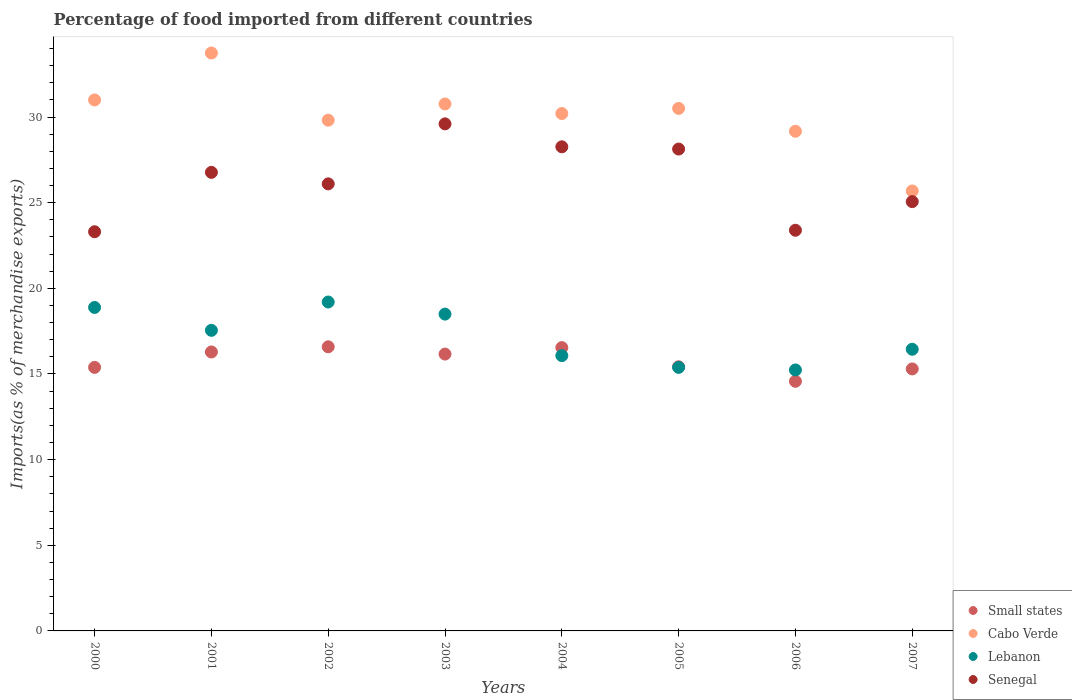What is the percentage of imports to different countries in Cabo Verde in 2002?
Make the answer very short. 29.82. Across all years, what is the maximum percentage of imports to different countries in Small states?
Offer a very short reply. 16.59. Across all years, what is the minimum percentage of imports to different countries in Senegal?
Keep it short and to the point. 23.3. In which year was the percentage of imports to different countries in Cabo Verde minimum?
Give a very brief answer. 2007. What is the total percentage of imports to different countries in Small states in the graph?
Your response must be concise. 126.25. What is the difference between the percentage of imports to different countries in Lebanon in 2002 and that in 2003?
Offer a terse response. 0.71. What is the difference between the percentage of imports to different countries in Senegal in 2006 and the percentage of imports to different countries in Small states in 2004?
Make the answer very short. 6.85. What is the average percentage of imports to different countries in Senegal per year?
Provide a short and direct response. 26.33. In the year 2001, what is the difference between the percentage of imports to different countries in Small states and percentage of imports to different countries in Senegal?
Provide a succinct answer. -10.49. What is the ratio of the percentage of imports to different countries in Lebanon in 2001 to that in 2003?
Offer a terse response. 0.95. What is the difference between the highest and the second highest percentage of imports to different countries in Senegal?
Provide a succinct answer. 1.34. What is the difference between the highest and the lowest percentage of imports to different countries in Small states?
Ensure brevity in your answer.  2.01. In how many years, is the percentage of imports to different countries in Lebanon greater than the average percentage of imports to different countries in Lebanon taken over all years?
Provide a short and direct response. 4. Is the sum of the percentage of imports to different countries in Lebanon in 2000 and 2006 greater than the maximum percentage of imports to different countries in Small states across all years?
Your answer should be compact. Yes. Is it the case that in every year, the sum of the percentage of imports to different countries in Senegal and percentage of imports to different countries in Cabo Verde  is greater than the percentage of imports to different countries in Lebanon?
Make the answer very short. Yes. Is the percentage of imports to different countries in Small states strictly greater than the percentage of imports to different countries in Lebanon over the years?
Offer a very short reply. No. How many years are there in the graph?
Your answer should be very brief. 8. What is the difference between two consecutive major ticks on the Y-axis?
Ensure brevity in your answer.  5. Are the values on the major ticks of Y-axis written in scientific E-notation?
Keep it short and to the point. No. Does the graph contain any zero values?
Your answer should be compact. No. How many legend labels are there?
Give a very brief answer. 4. What is the title of the graph?
Give a very brief answer. Percentage of food imported from different countries. What is the label or title of the Y-axis?
Ensure brevity in your answer.  Imports(as % of merchandise exports). What is the Imports(as % of merchandise exports) of Small states in 2000?
Provide a short and direct response. 15.39. What is the Imports(as % of merchandise exports) in Cabo Verde in 2000?
Offer a very short reply. 31. What is the Imports(as % of merchandise exports) of Lebanon in 2000?
Offer a very short reply. 18.88. What is the Imports(as % of merchandise exports) of Senegal in 2000?
Offer a terse response. 23.3. What is the Imports(as % of merchandise exports) in Small states in 2001?
Your answer should be very brief. 16.29. What is the Imports(as % of merchandise exports) in Cabo Verde in 2001?
Offer a very short reply. 33.74. What is the Imports(as % of merchandise exports) of Lebanon in 2001?
Ensure brevity in your answer.  17.55. What is the Imports(as % of merchandise exports) of Senegal in 2001?
Provide a short and direct response. 26.77. What is the Imports(as % of merchandise exports) in Small states in 2002?
Your answer should be very brief. 16.59. What is the Imports(as % of merchandise exports) in Cabo Verde in 2002?
Provide a short and direct response. 29.82. What is the Imports(as % of merchandise exports) in Lebanon in 2002?
Provide a short and direct response. 19.2. What is the Imports(as % of merchandise exports) in Senegal in 2002?
Ensure brevity in your answer.  26.1. What is the Imports(as % of merchandise exports) of Small states in 2003?
Your response must be concise. 16.16. What is the Imports(as % of merchandise exports) of Cabo Verde in 2003?
Your response must be concise. 30.76. What is the Imports(as % of merchandise exports) of Lebanon in 2003?
Offer a very short reply. 18.5. What is the Imports(as % of merchandise exports) of Senegal in 2003?
Provide a succinct answer. 29.6. What is the Imports(as % of merchandise exports) in Small states in 2004?
Your answer should be compact. 16.54. What is the Imports(as % of merchandise exports) of Cabo Verde in 2004?
Keep it short and to the point. 30.21. What is the Imports(as % of merchandise exports) of Lebanon in 2004?
Your answer should be compact. 16.07. What is the Imports(as % of merchandise exports) of Senegal in 2004?
Give a very brief answer. 28.26. What is the Imports(as % of merchandise exports) in Small states in 2005?
Your answer should be very brief. 15.42. What is the Imports(as % of merchandise exports) in Cabo Verde in 2005?
Ensure brevity in your answer.  30.51. What is the Imports(as % of merchandise exports) of Lebanon in 2005?
Provide a succinct answer. 15.39. What is the Imports(as % of merchandise exports) of Senegal in 2005?
Give a very brief answer. 28.13. What is the Imports(as % of merchandise exports) of Small states in 2006?
Your response must be concise. 14.57. What is the Imports(as % of merchandise exports) of Cabo Verde in 2006?
Provide a short and direct response. 29.17. What is the Imports(as % of merchandise exports) of Lebanon in 2006?
Offer a very short reply. 15.24. What is the Imports(as % of merchandise exports) in Senegal in 2006?
Offer a terse response. 23.39. What is the Imports(as % of merchandise exports) of Small states in 2007?
Offer a very short reply. 15.3. What is the Imports(as % of merchandise exports) of Cabo Verde in 2007?
Ensure brevity in your answer.  25.69. What is the Imports(as % of merchandise exports) of Lebanon in 2007?
Give a very brief answer. 16.44. What is the Imports(as % of merchandise exports) in Senegal in 2007?
Offer a very short reply. 25.06. Across all years, what is the maximum Imports(as % of merchandise exports) in Small states?
Provide a succinct answer. 16.59. Across all years, what is the maximum Imports(as % of merchandise exports) of Cabo Verde?
Offer a very short reply. 33.74. Across all years, what is the maximum Imports(as % of merchandise exports) of Lebanon?
Keep it short and to the point. 19.2. Across all years, what is the maximum Imports(as % of merchandise exports) of Senegal?
Give a very brief answer. 29.6. Across all years, what is the minimum Imports(as % of merchandise exports) in Small states?
Your answer should be compact. 14.57. Across all years, what is the minimum Imports(as % of merchandise exports) of Cabo Verde?
Keep it short and to the point. 25.69. Across all years, what is the minimum Imports(as % of merchandise exports) of Lebanon?
Provide a short and direct response. 15.24. Across all years, what is the minimum Imports(as % of merchandise exports) of Senegal?
Offer a very short reply. 23.3. What is the total Imports(as % of merchandise exports) of Small states in the graph?
Provide a short and direct response. 126.25. What is the total Imports(as % of merchandise exports) in Cabo Verde in the graph?
Provide a short and direct response. 240.89. What is the total Imports(as % of merchandise exports) in Lebanon in the graph?
Your response must be concise. 137.27. What is the total Imports(as % of merchandise exports) in Senegal in the graph?
Give a very brief answer. 210.63. What is the difference between the Imports(as % of merchandise exports) of Small states in 2000 and that in 2001?
Ensure brevity in your answer.  -0.9. What is the difference between the Imports(as % of merchandise exports) in Cabo Verde in 2000 and that in 2001?
Make the answer very short. -2.74. What is the difference between the Imports(as % of merchandise exports) of Lebanon in 2000 and that in 2001?
Give a very brief answer. 1.34. What is the difference between the Imports(as % of merchandise exports) in Senegal in 2000 and that in 2001?
Make the answer very short. -3.47. What is the difference between the Imports(as % of merchandise exports) in Small states in 2000 and that in 2002?
Offer a terse response. -1.2. What is the difference between the Imports(as % of merchandise exports) in Cabo Verde in 2000 and that in 2002?
Offer a very short reply. 1.18. What is the difference between the Imports(as % of merchandise exports) of Lebanon in 2000 and that in 2002?
Make the answer very short. -0.32. What is the difference between the Imports(as % of merchandise exports) of Senegal in 2000 and that in 2002?
Make the answer very short. -2.8. What is the difference between the Imports(as % of merchandise exports) of Small states in 2000 and that in 2003?
Offer a terse response. -0.78. What is the difference between the Imports(as % of merchandise exports) in Cabo Verde in 2000 and that in 2003?
Ensure brevity in your answer.  0.24. What is the difference between the Imports(as % of merchandise exports) of Lebanon in 2000 and that in 2003?
Your answer should be compact. 0.39. What is the difference between the Imports(as % of merchandise exports) in Senegal in 2000 and that in 2003?
Your answer should be compact. -6.3. What is the difference between the Imports(as % of merchandise exports) of Small states in 2000 and that in 2004?
Ensure brevity in your answer.  -1.15. What is the difference between the Imports(as % of merchandise exports) in Cabo Verde in 2000 and that in 2004?
Offer a terse response. 0.79. What is the difference between the Imports(as % of merchandise exports) of Lebanon in 2000 and that in 2004?
Give a very brief answer. 2.81. What is the difference between the Imports(as % of merchandise exports) of Senegal in 2000 and that in 2004?
Give a very brief answer. -4.96. What is the difference between the Imports(as % of merchandise exports) in Small states in 2000 and that in 2005?
Offer a terse response. -0.03. What is the difference between the Imports(as % of merchandise exports) in Cabo Verde in 2000 and that in 2005?
Your response must be concise. 0.49. What is the difference between the Imports(as % of merchandise exports) of Lebanon in 2000 and that in 2005?
Your response must be concise. 3.5. What is the difference between the Imports(as % of merchandise exports) of Senegal in 2000 and that in 2005?
Your answer should be compact. -4.83. What is the difference between the Imports(as % of merchandise exports) of Small states in 2000 and that in 2006?
Make the answer very short. 0.81. What is the difference between the Imports(as % of merchandise exports) in Cabo Verde in 2000 and that in 2006?
Ensure brevity in your answer.  1.83. What is the difference between the Imports(as % of merchandise exports) of Lebanon in 2000 and that in 2006?
Offer a terse response. 3.65. What is the difference between the Imports(as % of merchandise exports) of Senegal in 2000 and that in 2006?
Your answer should be very brief. -0.09. What is the difference between the Imports(as % of merchandise exports) of Small states in 2000 and that in 2007?
Your response must be concise. 0.09. What is the difference between the Imports(as % of merchandise exports) in Cabo Verde in 2000 and that in 2007?
Your answer should be very brief. 5.31. What is the difference between the Imports(as % of merchandise exports) of Lebanon in 2000 and that in 2007?
Offer a terse response. 2.44. What is the difference between the Imports(as % of merchandise exports) in Senegal in 2000 and that in 2007?
Ensure brevity in your answer.  -1.76. What is the difference between the Imports(as % of merchandise exports) in Small states in 2001 and that in 2002?
Give a very brief answer. -0.3. What is the difference between the Imports(as % of merchandise exports) of Cabo Verde in 2001 and that in 2002?
Your response must be concise. 3.92. What is the difference between the Imports(as % of merchandise exports) in Lebanon in 2001 and that in 2002?
Your answer should be compact. -1.65. What is the difference between the Imports(as % of merchandise exports) of Senegal in 2001 and that in 2002?
Offer a terse response. 0.67. What is the difference between the Imports(as % of merchandise exports) in Small states in 2001 and that in 2003?
Provide a short and direct response. 0.12. What is the difference between the Imports(as % of merchandise exports) of Cabo Verde in 2001 and that in 2003?
Keep it short and to the point. 2.98. What is the difference between the Imports(as % of merchandise exports) in Lebanon in 2001 and that in 2003?
Your answer should be very brief. -0.95. What is the difference between the Imports(as % of merchandise exports) in Senegal in 2001 and that in 2003?
Keep it short and to the point. -2.83. What is the difference between the Imports(as % of merchandise exports) of Small states in 2001 and that in 2004?
Your answer should be compact. -0.25. What is the difference between the Imports(as % of merchandise exports) of Cabo Verde in 2001 and that in 2004?
Provide a short and direct response. 3.53. What is the difference between the Imports(as % of merchandise exports) of Lebanon in 2001 and that in 2004?
Your answer should be very brief. 1.48. What is the difference between the Imports(as % of merchandise exports) in Senegal in 2001 and that in 2004?
Your answer should be compact. -1.49. What is the difference between the Imports(as % of merchandise exports) in Small states in 2001 and that in 2005?
Make the answer very short. 0.86. What is the difference between the Imports(as % of merchandise exports) of Cabo Verde in 2001 and that in 2005?
Your answer should be compact. 3.24. What is the difference between the Imports(as % of merchandise exports) in Lebanon in 2001 and that in 2005?
Your response must be concise. 2.16. What is the difference between the Imports(as % of merchandise exports) of Senegal in 2001 and that in 2005?
Provide a short and direct response. -1.36. What is the difference between the Imports(as % of merchandise exports) in Small states in 2001 and that in 2006?
Provide a short and direct response. 1.71. What is the difference between the Imports(as % of merchandise exports) in Cabo Verde in 2001 and that in 2006?
Provide a short and direct response. 4.57. What is the difference between the Imports(as % of merchandise exports) in Lebanon in 2001 and that in 2006?
Ensure brevity in your answer.  2.31. What is the difference between the Imports(as % of merchandise exports) in Senegal in 2001 and that in 2006?
Provide a succinct answer. 3.38. What is the difference between the Imports(as % of merchandise exports) in Cabo Verde in 2001 and that in 2007?
Offer a very short reply. 8.05. What is the difference between the Imports(as % of merchandise exports) in Lebanon in 2001 and that in 2007?
Offer a very short reply. 1.1. What is the difference between the Imports(as % of merchandise exports) of Senegal in 2001 and that in 2007?
Ensure brevity in your answer.  1.71. What is the difference between the Imports(as % of merchandise exports) in Small states in 2002 and that in 2003?
Ensure brevity in your answer.  0.42. What is the difference between the Imports(as % of merchandise exports) in Cabo Verde in 2002 and that in 2003?
Provide a succinct answer. -0.95. What is the difference between the Imports(as % of merchandise exports) in Lebanon in 2002 and that in 2003?
Make the answer very short. 0.71. What is the difference between the Imports(as % of merchandise exports) of Senegal in 2002 and that in 2003?
Your response must be concise. -3.5. What is the difference between the Imports(as % of merchandise exports) of Small states in 2002 and that in 2004?
Ensure brevity in your answer.  0.05. What is the difference between the Imports(as % of merchandise exports) of Cabo Verde in 2002 and that in 2004?
Offer a very short reply. -0.39. What is the difference between the Imports(as % of merchandise exports) in Lebanon in 2002 and that in 2004?
Ensure brevity in your answer.  3.13. What is the difference between the Imports(as % of merchandise exports) of Senegal in 2002 and that in 2004?
Keep it short and to the point. -2.16. What is the difference between the Imports(as % of merchandise exports) in Small states in 2002 and that in 2005?
Your answer should be very brief. 1.17. What is the difference between the Imports(as % of merchandise exports) of Cabo Verde in 2002 and that in 2005?
Your answer should be very brief. -0.69. What is the difference between the Imports(as % of merchandise exports) in Lebanon in 2002 and that in 2005?
Provide a short and direct response. 3.81. What is the difference between the Imports(as % of merchandise exports) in Senegal in 2002 and that in 2005?
Offer a terse response. -2.03. What is the difference between the Imports(as % of merchandise exports) of Small states in 2002 and that in 2006?
Offer a very short reply. 2.01. What is the difference between the Imports(as % of merchandise exports) in Cabo Verde in 2002 and that in 2006?
Give a very brief answer. 0.65. What is the difference between the Imports(as % of merchandise exports) of Lebanon in 2002 and that in 2006?
Offer a terse response. 3.97. What is the difference between the Imports(as % of merchandise exports) in Senegal in 2002 and that in 2006?
Your response must be concise. 2.71. What is the difference between the Imports(as % of merchandise exports) of Small states in 2002 and that in 2007?
Give a very brief answer. 1.29. What is the difference between the Imports(as % of merchandise exports) in Cabo Verde in 2002 and that in 2007?
Make the answer very short. 4.13. What is the difference between the Imports(as % of merchandise exports) in Lebanon in 2002 and that in 2007?
Your answer should be very brief. 2.76. What is the difference between the Imports(as % of merchandise exports) in Senegal in 2002 and that in 2007?
Keep it short and to the point. 1.04. What is the difference between the Imports(as % of merchandise exports) of Small states in 2003 and that in 2004?
Your response must be concise. -0.38. What is the difference between the Imports(as % of merchandise exports) of Cabo Verde in 2003 and that in 2004?
Give a very brief answer. 0.56. What is the difference between the Imports(as % of merchandise exports) in Lebanon in 2003 and that in 2004?
Keep it short and to the point. 2.42. What is the difference between the Imports(as % of merchandise exports) in Senegal in 2003 and that in 2004?
Keep it short and to the point. 1.34. What is the difference between the Imports(as % of merchandise exports) of Small states in 2003 and that in 2005?
Give a very brief answer. 0.74. What is the difference between the Imports(as % of merchandise exports) of Cabo Verde in 2003 and that in 2005?
Give a very brief answer. 0.26. What is the difference between the Imports(as % of merchandise exports) in Lebanon in 2003 and that in 2005?
Your response must be concise. 3.11. What is the difference between the Imports(as % of merchandise exports) in Senegal in 2003 and that in 2005?
Ensure brevity in your answer.  1.47. What is the difference between the Imports(as % of merchandise exports) in Small states in 2003 and that in 2006?
Give a very brief answer. 1.59. What is the difference between the Imports(as % of merchandise exports) in Cabo Verde in 2003 and that in 2006?
Offer a very short reply. 1.59. What is the difference between the Imports(as % of merchandise exports) of Lebanon in 2003 and that in 2006?
Give a very brief answer. 3.26. What is the difference between the Imports(as % of merchandise exports) in Senegal in 2003 and that in 2006?
Offer a terse response. 6.21. What is the difference between the Imports(as % of merchandise exports) in Small states in 2003 and that in 2007?
Offer a very short reply. 0.87. What is the difference between the Imports(as % of merchandise exports) of Cabo Verde in 2003 and that in 2007?
Offer a terse response. 5.08. What is the difference between the Imports(as % of merchandise exports) of Lebanon in 2003 and that in 2007?
Make the answer very short. 2.05. What is the difference between the Imports(as % of merchandise exports) in Senegal in 2003 and that in 2007?
Provide a succinct answer. 4.54. What is the difference between the Imports(as % of merchandise exports) of Small states in 2004 and that in 2005?
Keep it short and to the point. 1.12. What is the difference between the Imports(as % of merchandise exports) in Cabo Verde in 2004 and that in 2005?
Your answer should be compact. -0.3. What is the difference between the Imports(as % of merchandise exports) in Lebanon in 2004 and that in 2005?
Make the answer very short. 0.69. What is the difference between the Imports(as % of merchandise exports) in Senegal in 2004 and that in 2005?
Provide a succinct answer. 0.13. What is the difference between the Imports(as % of merchandise exports) in Small states in 2004 and that in 2006?
Offer a terse response. 1.97. What is the difference between the Imports(as % of merchandise exports) in Cabo Verde in 2004 and that in 2006?
Your response must be concise. 1.04. What is the difference between the Imports(as % of merchandise exports) of Lebanon in 2004 and that in 2006?
Keep it short and to the point. 0.84. What is the difference between the Imports(as % of merchandise exports) of Senegal in 2004 and that in 2006?
Your answer should be compact. 4.87. What is the difference between the Imports(as % of merchandise exports) of Small states in 2004 and that in 2007?
Make the answer very short. 1.24. What is the difference between the Imports(as % of merchandise exports) in Cabo Verde in 2004 and that in 2007?
Provide a short and direct response. 4.52. What is the difference between the Imports(as % of merchandise exports) of Lebanon in 2004 and that in 2007?
Keep it short and to the point. -0.37. What is the difference between the Imports(as % of merchandise exports) in Senegal in 2004 and that in 2007?
Your response must be concise. 3.2. What is the difference between the Imports(as % of merchandise exports) of Small states in 2005 and that in 2006?
Provide a succinct answer. 0.85. What is the difference between the Imports(as % of merchandise exports) in Cabo Verde in 2005 and that in 2006?
Provide a succinct answer. 1.33. What is the difference between the Imports(as % of merchandise exports) of Lebanon in 2005 and that in 2006?
Your answer should be very brief. 0.15. What is the difference between the Imports(as % of merchandise exports) of Senegal in 2005 and that in 2006?
Your response must be concise. 4.74. What is the difference between the Imports(as % of merchandise exports) of Small states in 2005 and that in 2007?
Offer a terse response. 0.13. What is the difference between the Imports(as % of merchandise exports) in Cabo Verde in 2005 and that in 2007?
Your response must be concise. 4.82. What is the difference between the Imports(as % of merchandise exports) of Lebanon in 2005 and that in 2007?
Ensure brevity in your answer.  -1.06. What is the difference between the Imports(as % of merchandise exports) of Senegal in 2005 and that in 2007?
Give a very brief answer. 3.07. What is the difference between the Imports(as % of merchandise exports) in Small states in 2006 and that in 2007?
Your answer should be very brief. -0.72. What is the difference between the Imports(as % of merchandise exports) of Cabo Verde in 2006 and that in 2007?
Provide a succinct answer. 3.48. What is the difference between the Imports(as % of merchandise exports) of Lebanon in 2006 and that in 2007?
Provide a succinct answer. -1.21. What is the difference between the Imports(as % of merchandise exports) of Senegal in 2006 and that in 2007?
Your answer should be very brief. -1.67. What is the difference between the Imports(as % of merchandise exports) in Small states in 2000 and the Imports(as % of merchandise exports) in Cabo Verde in 2001?
Give a very brief answer. -18.35. What is the difference between the Imports(as % of merchandise exports) in Small states in 2000 and the Imports(as % of merchandise exports) in Lebanon in 2001?
Your answer should be very brief. -2.16. What is the difference between the Imports(as % of merchandise exports) in Small states in 2000 and the Imports(as % of merchandise exports) in Senegal in 2001?
Give a very brief answer. -11.38. What is the difference between the Imports(as % of merchandise exports) in Cabo Verde in 2000 and the Imports(as % of merchandise exports) in Lebanon in 2001?
Your answer should be very brief. 13.45. What is the difference between the Imports(as % of merchandise exports) in Cabo Verde in 2000 and the Imports(as % of merchandise exports) in Senegal in 2001?
Offer a terse response. 4.23. What is the difference between the Imports(as % of merchandise exports) in Lebanon in 2000 and the Imports(as % of merchandise exports) in Senegal in 2001?
Keep it short and to the point. -7.89. What is the difference between the Imports(as % of merchandise exports) in Small states in 2000 and the Imports(as % of merchandise exports) in Cabo Verde in 2002?
Your answer should be very brief. -14.43. What is the difference between the Imports(as % of merchandise exports) in Small states in 2000 and the Imports(as % of merchandise exports) in Lebanon in 2002?
Make the answer very short. -3.82. What is the difference between the Imports(as % of merchandise exports) of Small states in 2000 and the Imports(as % of merchandise exports) of Senegal in 2002?
Ensure brevity in your answer.  -10.71. What is the difference between the Imports(as % of merchandise exports) of Cabo Verde in 2000 and the Imports(as % of merchandise exports) of Lebanon in 2002?
Give a very brief answer. 11.8. What is the difference between the Imports(as % of merchandise exports) in Cabo Verde in 2000 and the Imports(as % of merchandise exports) in Senegal in 2002?
Offer a very short reply. 4.9. What is the difference between the Imports(as % of merchandise exports) of Lebanon in 2000 and the Imports(as % of merchandise exports) of Senegal in 2002?
Your response must be concise. -7.22. What is the difference between the Imports(as % of merchandise exports) in Small states in 2000 and the Imports(as % of merchandise exports) in Cabo Verde in 2003?
Keep it short and to the point. -15.38. What is the difference between the Imports(as % of merchandise exports) of Small states in 2000 and the Imports(as % of merchandise exports) of Lebanon in 2003?
Offer a terse response. -3.11. What is the difference between the Imports(as % of merchandise exports) in Small states in 2000 and the Imports(as % of merchandise exports) in Senegal in 2003?
Ensure brevity in your answer.  -14.22. What is the difference between the Imports(as % of merchandise exports) of Cabo Verde in 2000 and the Imports(as % of merchandise exports) of Lebanon in 2003?
Your answer should be very brief. 12.5. What is the difference between the Imports(as % of merchandise exports) in Cabo Verde in 2000 and the Imports(as % of merchandise exports) in Senegal in 2003?
Ensure brevity in your answer.  1.4. What is the difference between the Imports(as % of merchandise exports) of Lebanon in 2000 and the Imports(as % of merchandise exports) of Senegal in 2003?
Give a very brief answer. -10.72. What is the difference between the Imports(as % of merchandise exports) in Small states in 2000 and the Imports(as % of merchandise exports) in Cabo Verde in 2004?
Offer a terse response. -14.82. What is the difference between the Imports(as % of merchandise exports) in Small states in 2000 and the Imports(as % of merchandise exports) in Lebanon in 2004?
Keep it short and to the point. -0.69. What is the difference between the Imports(as % of merchandise exports) in Small states in 2000 and the Imports(as % of merchandise exports) in Senegal in 2004?
Offer a terse response. -12.88. What is the difference between the Imports(as % of merchandise exports) in Cabo Verde in 2000 and the Imports(as % of merchandise exports) in Lebanon in 2004?
Provide a succinct answer. 14.93. What is the difference between the Imports(as % of merchandise exports) in Cabo Verde in 2000 and the Imports(as % of merchandise exports) in Senegal in 2004?
Your answer should be very brief. 2.74. What is the difference between the Imports(as % of merchandise exports) in Lebanon in 2000 and the Imports(as % of merchandise exports) in Senegal in 2004?
Keep it short and to the point. -9.38. What is the difference between the Imports(as % of merchandise exports) of Small states in 2000 and the Imports(as % of merchandise exports) of Cabo Verde in 2005?
Ensure brevity in your answer.  -15.12. What is the difference between the Imports(as % of merchandise exports) in Small states in 2000 and the Imports(as % of merchandise exports) in Lebanon in 2005?
Ensure brevity in your answer.  -0. What is the difference between the Imports(as % of merchandise exports) in Small states in 2000 and the Imports(as % of merchandise exports) in Senegal in 2005?
Ensure brevity in your answer.  -12.75. What is the difference between the Imports(as % of merchandise exports) in Cabo Verde in 2000 and the Imports(as % of merchandise exports) in Lebanon in 2005?
Your answer should be very brief. 15.61. What is the difference between the Imports(as % of merchandise exports) of Cabo Verde in 2000 and the Imports(as % of merchandise exports) of Senegal in 2005?
Offer a very short reply. 2.87. What is the difference between the Imports(as % of merchandise exports) of Lebanon in 2000 and the Imports(as % of merchandise exports) of Senegal in 2005?
Provide a short and direct response. -9.25. What is the difference between the Imports(as % of merchandise exports) of Small states in 2000 and the Imports(as % of merchandise exports) of Cabo Verde in 2006?
Offer a terse response. -13.78. What is the difference between the Imports(as % of merchandise exports) of Small states in 2000 and the Imports(as % of merchandise exports) of Lebanon in 2006?
Your answer should be compact. 0.15. What is the difference between the Imports(as % of merchandise exports) of Small states in 2000 and the Imports(as % of merchandise exports) of Senegal in 2006?
Your response must be concise. -8.01. What is the difference between the Imports(as % of merchandise exports) in Cabo Verde in 2000 and the Imports(as % of merchandise exports) in Lebanon in 2006?
Offer a very short reply. 15.76. What is the difference between the Imports(as % of merchandise exports) of Cabo Verde in 2000 and the Imports(as % of merchandise exports) of Senegal in 2006?
Provide a succinct answer. 7.61. What is the difference between the Imports(as % of merchandise exports) of Lebanon in 2000 and the Imports(as % of merchandise exports) of Senegal in 2006?
Offer a terse response. -4.51. What is the difference between the Imports(as % of merchandise exports) of Small states in 2000 and the Imports(as % of merchandise exports) of Cabo Verde in 2007?
Offer a very short reply. -10.3. What is the difference between the Imports(as % of merchandise exports) of Small states in 2000 and the Imports(as % of merchandise exports) of Lebanon in 2007?
Offer a very short reply. -1.06. What is the difference between the Imports(as % of merchandise exports) in Small states in 2000 and the Imports(as % of merchandise exports) in Senegal in 2007?
Ensure brevity in your answer.  -9.68. What is the difference between the Imports(as % of merchandise exports) in Cabo Verde in 2000 and the Imports(as % of merchandise exports) in Lebanon in 2007?
Provide a succinct answer. 14.56. What is the difference between the Imports(as % of merchandise exports) of Cabo Verde in 2000 and the Imports(as % of merchandise exports) of Senegal in 2007?
Your answer should be compact. 5.94. What is the difference between the Imports(as % of merchandise exports) in Lebanon in 2000 and the Imports(as % of merchandise exports) in Senegal in 2007?
Your response must be concise. -6.18. What is the difference between the Imports(as % of merchandise exports) of Small states in 2001 and the Imports(as % of merchandise exports) of Cabo Verde in 2002?
Your answer should be very brief. -13.53. What is the difference between the Imports(as % of merchandise exports) in Small states in 2001 and the Imports(as % of merchandise exports) in Lebanon in 2002?
Your answer should be very brief. -2.92. What is the difference between the Imports(as % of merchandise exports) in Small states in 2001 and the Imports(as % of merchandise exports) in Senegal in 2002?
Ensure brevity in your answer.  -9.81. What is the difference between the Imports(as % of merchandise exports) in Cabo Verde in 2001 and the Imports(as % of merchandise exports) in Lebanon in 2002?
Keep it short and to the point. 14.54. What is the difference between the Imports(as % of merchandise exports) in Cabo Verde in 2001 and the Imports(as % of merchandise exports) in Senegal in 2002?
Offer a very short reply. 7.64. What is the difference between the Imports(as % of merchandise exports) in Lebanon in 2001 and the Imports(as % of merchandise exports) in Senegal in 2002?
Offer a very short reply. -8.55. What is the difference between the Imports(as % of merchandise exports) in Small states in 2001 and the Imports(as % of merchandise exports) in Cabo Verde in 2003?
Make the answer very short. -14.48. What is the difference between the Imports(as % of merchandise exports) in Small states in 2001 and the Imports(as % of merchandise exports) in Lebanon in 2003?
Offer a very short reply. -2.21. What is the difference between the Imports(as % of merchandise exports) of Small states in 2001 and the Imports(as % of merchandise exports) of Senegal in 2003?
Your answer should be compact. -13.32. What is the difference between the Imports(as % of merchandise exports) in Cabo Verde in 2001 and the Imports(as % of merchandise exports) in Lebanon in 2003?
Make the answer very short. 15.24. What is the difference between the Imports(as % of merchandise exports) in Cabo Verde in 2001 and the Imports(as % of merchandise exports) in Senegal in 2003?
Your answer should be compact. 4.14. What is the difference between the Imports(as % of merchandise exports) of Lebanon in 2001 and the Imports(as % of merchandise exports) of Senegal in 2003?
Provide a succinct answer. -12.05. What is the difference between the Imports(as % of merchandise exports) in Small states in 2001 and the Imports(as % of merchandise exports) in Cabo Verde in 2004?
Give a very brief answer. -13.92. What is the difference between the Imports(as % of merchandise exports) of Small states in 2001 and the Imports(as % of merchandise exports) of Lebanon in 2004?
Offer a very short reply. 0.21. What is the difference between the Imports(as % of merchandise exports) in Small states in 2001 and the Imports(as % of merchandise exports) in Senegal in 2004?
Keep it short and to the point. -11.98. What is the difference between the Imports(as % of merchandise exports) in Cabo Verde in 2001 and the Imports(as % of merchandise exports) in Lebanon in 2004?
Make the answer very short. 17.67. What is the difference between the Imports(as % of merchandise exports) in Cabo Verde in 2001 and the Imports(as % of merchandise exports) in Senegal in 2004?
Your answer should be very brief. 5.48. What is the difference between the Imports(as % of merchandise exports) of Lebanon in 2001 and the Imports(as % of merchandise exports) of Senegal in 2004?
Give a very brief answer. -10.71. What is the difference between the Imports(as % of merchandise exports) in Small states in 2001 and the Imports(as % of merchandise exports) in Cabo Verde in 2005?
Make the answer very short. -14.22. What is the difference between the Imports(as % of merchandise exports) of Small states in 2001 and the Imports(as % of merchandise exports) of Lebanon in 2005?
Keep it short and to the point. 0.9. What is the difference between the Imports(as % of merchandise exports) of Small states in 2001 and the Imports(as % of merchandise exports) of Senegal in 2005?
Your answer should be compact. -11.85. What is the difference between the Imports(as % of merchandise exports) of Cabo Verde in 2001 and the Imports(as % of merchandise exports) of Lebanon in 2005?
Give a very brief answer. 18.35. What is the difference between the Imports(as % of merchandise exports) in Cabo Verde in 2001 and the Imports(as % of merchandise exports) in Senegal in 2005?
Provide a succinct answer. 5.61. What is the difference between the Imports(as % of merchandise exports) of Lebanon in 2001 and the Imports(as % of merchandise exports) of Senegal in 2005?
Make the answer very short. -10.58. What is the difference between the Imports(as % of merchandise exports) of Small states in 2001 and the Imports(as % of merchandise exports) of Cabo Verde in 2006?
Ensure brevity in your answer.  -12.89. What is the difference between the Imports(as % of merchandise exports) in Small states in 2001 and the Imports(as % of merchandise exports) in Lebanon in 2006?
Keep it short and to the point. 1.05. What is the difference between the Imports(as % of merchandise exports) of Small states in 2001 and the Imports(as % of merchandise exports) of Senegal in 2006?
Give a very brief answer. -7.11. What is the difference between the Imports(as % of merchandise exports) in Cabo Verde in 2001 and the Imports(as % of merchandise exports) in Lebanon in 2006?
Your answer should be compact. 18.5. What is the difference between the Imports(as % of merchandise exports) of Cabo Verde in 2001 and the Imports(as % of merchandise exports) of Senegal in 2006?
Keep it short and to the point. 10.35. What is the difference between the Imports(as % of merchandise exports) of Lebanon in 2001 and the Imports(as % of merchandise exports) of Senegal in 2006?
Offer a very short reply. -5.84. What is the difference between the Imports(as % of merchandise exports) of Small states in 2001 and the Imports(as % of merchandise exports) of Cabo Verde in 2007?
Provide a short and direct response. -9.4. What is the difference between the Imports(as % of merchandise exports) in Small states in 2001 and the Imports(as % of merchandise exports) in Lebanon in 2007?
Your answer should be compact. -0.16. What is the difference between the Imports(as % of merchandise exports) of Small states in 2001 and the Imports(as % of merchandise exports) of Senegal in 2007?
Ensure brevity in your answer.  -8.78. What is the difference between the Imports(as % of merchandise exports) of Cabo Verde in 2001 and the Imports(as % of merchandise exports) of Lebanon in 2007?
Keep it short and to the point. 17.3. What is the difference between the Imports(as % of merchandise exports) of Cabo Verde in 2001 and the Imports(as % of merchandise exports) of Senegal in 2007?
Give a very brief answer. 8.68. What is the difference between the Imports(as % of merchandise exports) of Lebanon in 2001 and the Imports(as % of merchandise exports) of Senegal in 2007?
Offer a very short reply. -7.51. What is the difference between the Imports(as % of merchandise exports) of Small states in 2002 and the Imports(as % of merchandise exports) of Cabo Verde in 2003?
Your answer should be very brief. -14.18. What is the difference between the Imports(as % of merchandise exports) of Small states in 2002 and the Imports(as % of merchandise exports) of Lebanon in 2003?
Provide a succinct answer. -1.91. What is the difference between the Imports(as % of merchandise exports) in Small states in 2002 and the Imports(as % of merchandise exports) in Senegal in 2003?
Provide a succinct answer. -13.02. What is the difference between the Imports(as % of merchandise exports) in Cabo Verde in 2002 and the Imports(as % of merchandise exports) in Lebanon in 2003?
Your answer should be very brief. 11.32. What is the difference between the Imports(as % of merchandise exports) in Cabo Verde in 2002 and the Imports(as % of merchandise exports) in Senegal in 2003?
Make the answer very short. 0.22. What is the difference between the Imports(as % of merchandise exports) in Lebanon in 2002 and the Imports(as % of merchandise exports) in Senegal in 2003?
Make the answer very short. -10.4. What is the difference between the Imports(as % of merchandise exports) in Small states in 2002 and the Imports(as % of merchandise exports) in Cabo Verde in 2004?
Your answer should be very brief. -13.62. What is the difference between the Imports(as % of merchandise exports) in Small states in 2002 and the Imports(as % of merchandise exports) in Lebanon in 2004?
Your answer should be very brief. 0.51. What is the difference between the Imports(as % of merchandise exports) in Small states in 2002 and the Imports(as % of merchandise exports) in Senegal in 2004?
Provide a succinct answer. -11.68. What is the difference between the Imports(as % of merchandise exports) of Cabo Verde in 2002 and the Imports(as % of merchandise exports) of Lebanon in 2004?
Provide a short and direct response. 13.75. What is the difference between the Imports(as % of merchandise exports) in Cabo Verde in 2002 and the Imports(as % of merchandise exports) in Senegal in 2004?
Offer a terse response. 1.55. What is the difference between the Imports(as % of merchandise exports) of Lebanon in 2002 and the Imports(as % of merchandise exports) of Senegal in 2004?
Provide a succinct answer. -9.06. What is the difference between the Imports(as % of merchandise exports) in Small states in 2002 and the Imports(as % of merchandise exports) in Cabo Verde in 2005?
Provide a short and direct response. -13.92. What is the difference between the Imports(as % of merchandise exports) in Small states in 2002 and the Imports(as % of merchandise exports) in Lebanon in 2005?
Make the answer very short. 1.2. What is the difference between the Imports(as % of merchandise exports) of Small states in 2002 and the Imports(as % of merchandise exports) of Senegal in 2005?
Make the answer very short. -11.54. What is the difference between the Imports(as % of merchandise exports) of Cabo Verde in 2002 and the Imports(as % of merchandise exports) of Lebanon in 2005?
Your answer should be very brief. 14.43. What is the difference between the Imports(as % of merchandise exports) in Cabo Verde in 2002 and the Imports(as % of merchandise exports) in Senegal in 2005?
Your response must be concise. 1.69. What is the difference between the Imports(as % of merchandise exports) in Lebanon in 2002 and the Imports(as % of merchandise exports) in Senegal in 2005?
Your answer should be compact. -8.93. What is the difference between the Imports(as % of merchandise exports) of Small states in 2002 and the Imports(as % of merchandise exports) of Cabo Verde in 2006?
Give a very brief answer. -12.58. What is the difference between the Imports(as % of merchandise exports) in Small states in 2002 and the Imports(as % of merchandise exports) in Lebanon in 2006?
Provide a succinct answer. 1.35. What is the difference between the Imports(as % of merchandise exports) in Small states in 2002 and the Imports(as % of merchandise exports) in Senegal in 2006?
Keep it short and to the point. -6.8. What is the difference between the Imports(as % of merchandise exports) in Cabo Verde in 2002 and the Imports(as % of merchandise exports) in Lebanon in 2006?
Your answer should be compact. 14.58. What is the difference between the Imports(as % of merchandise exports) in Cabo Verde in 2002 and the Imports(as % of merchandise exports) in Senegal in 2006?
Ensure brevity in your answer.  6.43. What is the difference between the Imports(as % of merchandise exports) of Lebanon in 2002 and the Imports(as % of merchandise exports) of Senegal in 2006?
Ensure brevity in your answer.  -4.19. What is the difference between the Imports(as % of merchandise exports) in Small states in 2002 and the Imports(as % of merchandise exports) in Cabo Verde in 2007?
Give a very brief answer. -9.1. What is the difference between the Imports(as % of merchandise exports) in Small states in 2002 and the Imports(as % of merchandise exports) in Lebanon in 2007?
Keep it short and to the point. 0.14. What is the difference between the Imports(as % of merchandise exports) of Small states in 2002 and the Imports(as % of merchandise exports) of Senegal in 2007?
Give a very brief answer. -8.48. What is the difference between the Imports(as % of merchandise exports) of Cabo Verde in 2002 and the Imports(as % of merchandise exports) of Lebanon in 2007?
Offer a very short reply. 13.37. What is the difference between the Imports(as % of merchandise exports) of Cabo Verde in 2002 and the Imports(as % of merchandise exports) of Senegal in 2007?
Offer a terse response. 4.75. What is the difference between the Imports(as % of merchandise exports) in Lebanon in 2002 and the Imports(as % of merchandise exports) in Senegal in 2007?
Give a very brief answer. -5.86. What is the difference between the Imports(as % of merchandise exports) of Small states in 2003 and the Imports(as % of merchandise exports) of Cabo Verde in 2004?
Keep it short and to the point. -14.04. What is the difference between the Imports(as % of merchandise exports) in Small states in 2003 and the Imports(as % of merchandise exports) in Lebanon in 2004?
Your answer should be very brief. 0.09. What is the difference between the Imports(as % of merchandise exports) in Small states in 2003 and the Imports(as % of merchandise exports) in Senegal in 2004?
Your answer should be very brief. -12.1. What is the difference between the Imports(as % of merchandise exports) of Cabo Verde in 2003 and the Imports(as % of merchandise exports) of Lebanon in 2004?
Ensure brevity in your answer.  14.69. What is the difference between the Imports(as % of merchandise exports) of Cabo Verde in 2003 and the Imports(as % of merchandise exports) of Senegal in 2004?
Keep it short and to the point. 2.5. What is the difference between the Imports(as % of merchandise exports) in Lebanon in 2003 and the Imports(as % of merchandise exports) in Senegal in 2004?
Provide a succinct answer. -9.77. What is the difference between the Imports(as % of merchandise exports) in Small states in 2003 and the Imports(as % of merchandise exports) in Cabo Verde in 2005?
Provide a short and direct response. -14.34. What is the difference between the Imports(as % of merchandise exports) of Small states in 2003 and the Imports(as % of merchandise exports) of Lebanon in 2005?
Provide a succinct answer. 0.78. What is the difference between the Imports(as % of merchandise exports) of Small states in 2003 and the Imports(as % of merchandise exports) of Senegal in 2005?
Your answer should be very brief. -11.97. What is the difference between the Imports(as % of merchandise exports) in Cabo Verde in 2003 and the Imports(as % of merchandise exports) in Lebanon in 2005?
Give a very brief answer. 15.38. What is the difference between the Imports(as % of merchandise exports) in Cabo Verde in 2003 and the Imports(as % of merchandise exports) in Senegal in 2005?
Offer a very short reply. 2.63. What is the difference between the Imports(as % of merchandise exports) of Lebanon in 2003 and the Imports(as % of merchandise exports) of Senegal in 2005?
Make the answer very short. -9.64. What is the difference between the Imports(as % of merchandise exports) in Small states in 2003 and the Imports(as % of merchandise exports) in Cabo Verde in 2006?
Keep it short and to the point. -13.01. What is the difference between the Imports(as % of merchandise exports) of Small states in 2003 and the Imports(as % of merchandise exports) of Lebanon in 2006?
Provide a short and direct response. 0.93. What is the difference between the Imports(as % of merchandise exports) of Small states in 2003 and the Imports(as % of merchandise exports) of Senegal in 2006?
Give a very brief answer. -7.23. What is the difference between the Imports(as % of merchandise exports) of Cabo Verde in 2003 and the Imports(as % of merchandise exports) of Lebanon in 2006?
Keep it short and to the point. 15.53. What is the difference between the Imports(as % of merchandise exports) of Cabo Verde in 2003 and the Imports(as % of merchandise exports) of Senegal in 2006?
Your answer should be compact. 7.37. What is the difference between the Imports(as % of merchandise exports) of Lebanon in 2003 and the Imports(as % of merchandise exports) of Senegal in 2006?
Provide a short and direct response. -4.9. What is the difference between the Imports(as % of merchandise exports) in Small states in 2003 and the Imports(as % of merchandise exports) in Cabo Verde in 2007?
Make the answer very short. -9.52. What is the difference between the Imports(as % of merchandise exports) in Small states in 2003 and the Imports(as % of merchandise exports) in Lebanon in 2007?
Make the answer very short. -0.28. What is the difference between the Imports(as % of merchandise exports) in Small states in 2003 and the Imports(as % of merchandise exports) in Senegal in 2007?
Provide a short and direct response. -8.9. What is the difference between the Imports(as % of merchandise exports) in Cabo Verde in 2003 and the Imports(as % of merchandise exports) in Lebanon in 2007?
Ensure brevity in your answer.  14.32. What is the difference between the Imports(as % of merchandise exports) in Cabo Verde in 2003 and the Imports(as % of merchandise exports) in Senegal in 2007?
Provide a succinct answer. 5.7. What is the difference between the Imports(as % of merchandise exports) in Lebanon in 2003 and the Imports(as % of merchandise exports) in Senegal in 2007?
Give a very brief answer. -6.57. What is the difference between the Imports(as % of merchandise exports) of Small states in 2004 and the Imports(as % of merchandise exports) of Cabo Verde in 2005?
Keep it short and to the point. -13.97. What is the difference between the Imports(as % of merchandise exports) in Small states in 2004 and the Imports(as % of merchandise exports) in Lebanon in 2005?
Ensure brevity in your answer.  1.15. What is the difference between the Imports(as % of merchandise exports) in Small states in 2004 and the Imports(as % of merchandise exports) in Senegal in 2005?
Provide a succinct answer. -11.59. What is the difference between the Imports(as % of merchandise exports) of Cabo Verde in 2004 and the Imports(as % of merchandise exports) of Lebanon in 2005?
Provide a succinct answer. 14.82. What is the difference between the Imports(as % of merchandise exports) in Cabo Verde in 2004 and the Imports(as % of merchandise exports) in Senegal in 2005?
Offer a terse response. 2.07. What is the difference between the Imports(as % of merchandise exports) in Lebanon in 2004 and the Imports(as % of merchandise exports) in Senegal in 2005?
Give a very brief answer. -12.06. What is the difference between the Imports(as % of merchandise exports) in Small states in 2004 and the Imports(as % of merchandise exports) in Cabo Verde in 2006?
Give a very brief answer. -12.63. What is the difference between the Imports(as % of merchandise exports) of Small states in 2004 and the Imports(as % of merchandise exports) of Lebanon in 2006?
Offer a very short reply. 1.3. What is the difference between the Imports(as % of merchandise exports) in Small states in 2004 and the Imports(as % of merchandise exports) in Senegal in 2006?
Keep it short and to the point. -6.85. What is the difference between the Imports(as % of merchandise exports) of Cabo Verde in 2004 and the Imports(as % of merchandise exports) of Lebanon in 2006?
Offer a very short reply. 14.97. What is the difference between the Imports(as % of merchandise exports) in Cabo Verde in 2004 and the Imports(as % of merchandise exports) in Senegal in 2006?
Your answer should be very brief. 6.82. What is the difference between the Imports(as % of merchandise exports) of Lebanon in 2004 and the Imports(as % of merchandise exports) of Senegal in 2006?
Ensure brevity in your answer.  -7.32. What is the difference between the Imports(as % of merchandise exports) of Small states in 2004 and the Imports(as % of merchandise exports) of Cabo Verde in 2007?
Keep it short and to the point. -9.15. What is the difference between the Imports(as % of merchandise exports) in Small states in 2004 and the Imports(as % of merchandise exports) in Lebanon in 2007?
Ensure brevity in your answer.  0.1. What is the difference between the Imports(as % of merchandise exports) in Small states in 2004 and the Imports(as % of merchandise exports) in Senegal in 2007?
Your answer should be very brief. -8.52. What is the difference between the Imports(as % of merchandise exports) in Cabo Verde in 2004 and the Imports(as % of merchandise exports) in Lebanon in 2007?
Offer a terse response. 13.76. What is the difference between the Imports(as % of merchandise exports) in Cabo Verde in 2004 and the Imports(as % of merchandise exports) in Senegal in 2007?
Your response must be concise. 5.14. What is the difference between the Imports(as % of merchandise exports) of Lebanon in 2004 and the Imports(as % of merchandise exports) of Senegal in 2007?
Make the answer very short. -8.99. What is the difference between the Imports(as % of merchandise exports) of Small states in 2005 and the Imports(as % of merchandise exports) of Cabo Verde in 2006?
Offer a very short reply. -13.75. What is the difference between the Imports(as % of merchandise exports) in Small states in 2005 and the Imports(as % of merchandise exports) in Lebanon in 2006?
Offer a very short reply. 0.19. What is the difference between the Imports(as % of merchandise exports) in Small states in 2005 and the Imports(as % of merchandise exports) in Senegal in 2006?
Provide a short and direct response. -7.97. What is the difference between the Imports(as % of merchandise exports) of Cabo Verde in 2005 and the Imports(as % of merchandise exports) of Lebanon in 2006?
Your response must be concise. 15.27. What is the difference between the Imports(as % of merchandise exports) of Cabo Verde in 2005 and the Imports(as % of merchandise exports) of Senegal in 2006?
Your response must be concise. 7.11. What is the difference between the Imports(as % of merchandise exports) in Lebanon in 2005 and the Imports(as % of merchandise exports) in Senegal in 2006?
Your answer should be very brief. -8. What is the difference between the Imports(as % of merchandise exports) in Small states in 2005 and the Imports(as % of merchandise exports) in Cabo Verde in 2007?
Keep it short and to the point. -10.26. What is the difference between the Imports(as % of merchandise exports) in Small states in 2005 and the Imports(as % of merchandise exports) in Lebanon in 2007?
Offer a very short reply. -1.02. What is the difference between the Imports(as % of merchandise exports) in Small states in 2005 and the Imports(as % of merchandise exports) in Senegal in 2007?
Offer a terse response. -9.64. What is the difference between the Imports(as % of merchandise exports) in Cabo Verde in 2005 and the Imports(as % of merchandise exports) in Lebanon in 2007?
Ensure brevity in your answer.  14.06. What is the difference between the Imports(as % of merchandise exports) in Cabo Verde in 2005 and the Imports(as % of merchandise exports) in Senegal in 2007?
Make the answer very short. 5.44. What is the difference between the Imports(as % of merchandise exports) in Lebanon in 2005 and the Imports(as % of merchandise exports) in Senegal in 2007?
Your answer should be compact. -9.68. What is the difference between the Imports(as % of merchandise exports) in Small states in 2006 and the Imports(as % of merchandise exports) in Cabo Verde in 2007?
Ensure brevity in your answer.  -11.11. What is the difference between the Imports(as % of merchandise exports) in Small states in 2006 and the Imports(as % of merchandise exports) in Lebanon in 2007?
Ensure brevity in your answer.  -1.87. What is the difference between the Imports(as % of merchandise exports) of Small states in 2006 and the Imports(as % of merchandise exports) of Senegal in 2007?
Make the answer very short. -10.49. What is the difference between the Imports(as % of merchandise exports) in Cabo Verde in 2006 and the Imports(as % of merchandise exports) in Lebanon in 2007?
Provide a succinct answer. 12.73. What is the difference between the Imports(as % of merchandise exports) of Cabo Verde in 2006 and the Imports(as % of merchandise exports) of Senegal in 2007?
Keep it short and to the point. 4.11. What is the difference between the Imports(as % of merchandise exports) of Lebanon in 2006 and the Imports(as % of merchandise exports) of Senegal in 2007?
Keep it short and to the point. -9.83. What is the average Imports(as % of merchandise exports) in Small states per year?
Your answer should be very brief. 15.78. What is the average Imports(as % of merchandise exports) of Cabo Verde per year?
Your answer should be very brief. 30.11. What is the average Imports(as % of merchandise exports) in Lebanon per year?
Your answer should be compact. 17.16. What is the average Imports(as % of merchandise exports) in Senegal per year?
Your answer should be compact. 26.33. In the year 2000, what is the difference between the Imports(as % of merchandise exports) in Small states and Imports(as % of merchandise exports) in Cabo Verde?
Make the answer very short. -15.61. In the year 2000, what is the difference between the Imports(as % of merchandise exports) in Small states and Imports(as % of merchandise exports) in Lebanon?
Offer a terse response. -3.5. In the year 2000, what is the difference between the Imports(as % of merchandise exports) of Small states and Imports(as % of merchandise exports) of Senegal?
Provide a short and direct response. -7.92. In the year 2000, what is the difference between the Imports(as % of merchandise exports) of Cabo Verde and Imports(as % of merchandise exports) of Lebanon?
Give a very brief answer. 12.12. In the year 2000, what is the difference between the Imports(as % of merchandise exports) in Cabo Verde and Imports(as % of merchandise exports) in Senegal?
Your response must be concise. 7.7. In the year 2000, what is the difference between the Imports(as % of merchandise exports) of Lebanon and Imports(as % of merchandise exports) of Senegal?
Make the answer very short. -4.42. In the year 2001, what is the difference between the Imports(as % of merchandise exports) of Small states and Imports(as % of merchandise exports) of Cabo Verde?
Your answer should be very brief. -17.46. In the year 2001, what is the difference between the Imports(as % of merchandise exports) in Small states and Imports(as % of merchandise exports) in Lebanon?
Provide a succinct answer. -1.26. In the year 2001, what is the difference between the Imports(as % of merchandise exports) of Small states and Imports(as % of merchandise exports) of Senegal?
Make the answer very short. -10.49. In the year 2001, what is the difference between the Imports(as % of merchandise exports) in Cabo Verde and Imports(as % of merchandise exports) in Lebanon?
Provide a succinct answer. 16.19. In the year 2001, what is the difference between the Imports(as % of merchandise exports) in Cabo Verde and Imports(as % of merchandise exports) in Senegal?
Provide a short and direct response. 6.97. In the year 2001, what is the difference between the Imports(as % of merchandise exports) of Lebanon and Imports(as % of merchandise exports) of Senegal?
Keep it short and to the point. -9.22. In the year 2002, what is the difference between the Imports(as % of merchandise exports) of Small states and Imports(as % of merchandise exports) of Cabo Verde?
Offer a very short reply. -13.23. In the year 2002, what is the difference between the Imports(as % of merchandise exports) in Small states and Imports(as % of merchandise exports) in Lebanon?
Offer a terse response. -2.62. In the year 2002, what is the difference between the Imports(as % of merchandise exports) of Small states and Imports(as % of merchandise exports) of Senegal?
Give a very brief answer. -9.51. In the year 2002, what is the difference between the Imports(as % of merchandise exports) in Cabo Verde and Imports(as % of merchandise exports) in Lebanon?
Keep it short and to the point. 10.62. In the year 2002, what is the difference between the Imports(as % of merchandise exports) in Cabo Verde and Imports(as % of merchandise exports) in Senegal?
Make the answer very short. 3.72. In the year 2002, what is the difference between the Imports(as % of merchandise exports) in Lebanon and Imports(as % of merchandise exports) in Senegal?
Your answer should be compact. -6.9. In the year 2003, what is the difference between the Imports(as % of merchandise exports) in Small states and Imports(as % of merchandise exports) in Cabo Verde?
Your response must be concise. -14.6. In the year 2003, what is the difference between the Imports(as % of merchandise exports) in Small states and Imports(as % of merchandise exports) in Lebanon?
Offer a terse response. -2.33. In the year 2003, what is the difference between the Imports(as % of merchandise exports) of Small states and Imports(as % of merchandise exports) of Senegal?
Provide a succinct answer. -13.44. In the year 2003, what is the difference between the Imports(as % of merchandise exports) in Cabo Verde and Imports(as % of merchandise exports) in Lebanon?
Give a very brief answer. 12.27. In the year 2003, what is the difference between the Imports(as % of merchandise exports) in Cabo Verde and Imports(as % of merchandise exports) in Senegal?
Give a very brief answer. 1.16. In the year 2003, what is the difference between the Imports(as % of merchandise exports) of Lebanon and Imports(as % of merchandise exports) of Senegal?
Make the answer very short. -11.11. In the year 2004, what is the difference between the Imports(as % of merchandise exports) in Small states and Imports(as % of merchandise exports) in Cabo Verde?
Provide a short and direct response. -13.67. In the year 2004, what is the difference between the Imports(as % of merchandise exports) of Small states and Imports(as % of merchandise exports) of Lebanon?
Provide a succinct answer. 0.47. In the year 2004, what is the difference between the Imports(as % of merchandise exports) of Small states and Imports(as % of merchandise exports) of Senegal?
Keep it short and to the point. -11.72. In the year 2004, what is the difference between the Imports(as % of merchandise exports) in Cabo Verde and Imports(as % of merchandise exports) in Lebanon?
Offer a terse response. 14.13. In the year 2004, what is the difference between the Imports(as % of merchandise exports) in Cabo Verde and Imports(as % of merchandise exports) in Senegal?
Keep it short and to the point. 1.94. In the year 2004, what is the difference between the Imports(as % of merchandise exports) of Lebanon and Imports(as % of merchandise exports) of Senegal?
Your response must be concise. -12.19. In the year 2005, what is the difference between the Imports(as % of merchandise exports) of Small states and Imports(as % of merchandise exports) of Cabo Verde?
Provide a succinct answer. -15.08. In the year 2005, what is the difference between the Imports(as % of merchandise exports) in Small states and Imports(as % of merchandise exports) in Lebanon?
Your response must be concise. 0.03. In the year 2005, what is the difference between the Imports(as % of merchandise exports) in Small states and Imports(as % of merchandise exports) in Senegal?
Ensure brevity in your answer.  -12.71. In the year 2005, what is the difference between the Imports(as % of merchandise exports) in Cabo Verde and Imports(as % of merchandise exports) in Lebanon?
Your response must be concise. 15.12. In the year 2005, what is the difference between the Imports(as % of merchandise exports) in Cabo Verde and Imports(as % of merchandise exports) in Senegal?
Your response must be concise. 2.37. In the year 2005, what is the difference between the Imports(as % of merchandise exports) of Lebanon and Imports(as % of merchandise exports) of Senegal?
Provide a short and direct response. -12.74. In the year 2006, what is the difference between the Imports(as % of merchandise exports) in Small states and Imports(as % of merchandise exports) in Cabo Verde?
Keep it short and to the point. -14.6. In the year 2006, what is the difference between the Imports(as % of merchandise exports) of Small states and Imports(as % of merchandise exports) of Lebanon?
Offer a very short reply. -0.66. In the year 2006, what is the difference between the Imports(as % of merchandise exports) in Small states and Imports(as % of merchandise exports) in Senegal?
Make the answer very short. -8.82. In the year 2006, what is the difference between the Imports(as % of merchandise exports) in Cabo Verde and Imports(as % of merchandise exports) in Lebanon?
Your answer should be very brief. 13.94. In the year 2006, what is the difference between the Imports(as % of merchandise exports) in Cabo Verde and Imports(as % of merchandise exports) in Senegal?
Offer a very short reply. 5.78. In the year 2006, what is the difference between the Imports(as % of merchandise exports) of Lebanon and Imports(as % of merchandise exports) of Senegal?
Make the answer very short. -8.16. In the year 2007, what is the difference between the Imports(as % of merchandise exports) in Small states and Imports(as % of merchandise exports) in Cabo Verde?
Give a very brief answer. -10.39. In the year 2007, what is the difference between the Imports(as % of merchandise exports) in Small states and Imports(as % of merchandise exports) in Lebanon?
Your answer should be very brief. -1.15. In the year 2007, what is the difference between the Imports(as % of merchandise exports) of Small states and Imports(as % of merchandise exports) of Senegal?
Provide a short and direct response. -9.77. In the year 2007, what is the difference between the Imports(as % of merchandise exports) of Cabo Verde and Imports(as % of merchandise exports) of Lebanon?
Give a very brief answer. 9.24. In the year 2007, what is the difference between the Imports(as % of merchandise exports) of Cabo Verde and Imports(as % of merchandise exports) of Senegal?
Ensure brevity in your answer.  0.62. In the year 2007, what is the difference between the Imports(as % of merchandise exports) in Lebanon and Imports(as % of merchandise exports) in Senegal?
Your answer should be compact. -8.62. What is the ratio of the Imports(as % of merchandise exports) in Small states in 2000 to that in 2001?
Ensure brevity in your answer.  0.94. What is the ratio of the Imports(as % of merchandise exports) in Cabo Verde in 2000 to that in 2001?
Ensure brevity in your answer.  0.92. What is the ratio of the Imports(as % of merchandise exports) of Lebanon in 2000 to that in 2001?
Ensure brevity in your answer.  1.08. What is the ratio of the Imports(as % of merchandise exports) of Senegal in 2000 to that in 2001?
Your response must be concise. 0.87. What is the ratio of the Imports(as % of merchandise exports) of Small states in 2000 to that in 2002?
Offer a terse response. 0.93. What is the ratio of the Imports(as % of merchandise exports) in Cabo Verde in 2000 to that in 2002?
Keep it short and to the point. 1.04. What is the ratio of the Imports(as % of merchandise exports) of Lebanon in 2000 to that in 2002?
Keep it short and to the point. 0.98. What is the ratio of the Imports(as % of merchandise exports) in Senegal in 2000 to that in 2002?
Your answer should be compact. 0.89. What is the ratio of the Imports(as % of merchandise exports) in Cabo Verde in 2000 to that in 2003?
Make the answer very short. 1.01. What is the ratio of the Imports(as % of merchandise exports) in Senegal in 2000 to that in 2003?
Provide a succinct answer. 0.79. What is the ratio of the Imports(as % of merchandise exports) of Small states in 2000 to that in 2004?
Offer a terse response. 0.93. What is the ratio of the Imports(as % of merchandise exports) in Cabo Verde in 2000 to that in 2004?
Your answer should be compact. 1.03. What is the ratio of the Imports(as % of merchandise exports) of Lebanon in 2000 to that in 2004?
Make the answer very short. 1.17. What is the ratio of the Imports(as % of merchandise exports) in Senegal in 2000 to that in 2004?
Make the answer very short. 0.82. What is the ratio of the Imports(as % of merchandise exports) of Cabo Verde in 2000 to that in 2005?
Your answer should be very brief. 1.02. What is the ratio of the Imports(as % of merchandise exports) of Lebanon in 2000 to that in 2005?
Provide a succinct answer. 1.23. What is the ratio of the Imports(as % of merchandise exports) of Senegal in 2000 to that in 2005?
Your response must be concise. 0.83. What is the ratio of the Imports(as % of merchandise exports) in Small states in 2000 to that in 2006?
Your answer should be compact. 1.06. What is the ratio of the Imports(as % of merchandise exports) in Cabo Verde in 2000 to that in 2006?
Make the answer very short. 1.06. What is the ratio of the Imports(as % of merchandise exports) of Lebanon in 2000 to that in 2006?
Your response must be concise. 1.24. What is the ratio of the Imports(as % of merchandise exports) in Senegal in 2000 to that in 2006?
Give a very brief answer. 1. What is the ratio of the Imports(as % of merchandise exports) of Cabo Verde in 2000 to that in 2007?
Make the answer very short. 1.21. What is the ratio of the Imports(as % of merchandise exports) of Lebanon in 2000 to that in 2007?
Provide a succinct answer. 1.15. What is the ratio of the Imports(as % of merchandise exports) in Senegal in 2000 to that in 2007?
Make the answer very short. 0.93. What is the ratio of the Imports(as % of merchandise exports) in Small states in 2001 to that in 2002?
Ensure brevity in your answer.  0.98. What is the ratio of the Imports(as % of merchandise exports) in Cabo Verde in 2001 to that in 2002?
Your answer should be very brief. 1.13. What is the ratio of the Imports(as % of merchandise exports) of Lebanon in 2001 to that in 2002?
Your response must be concise. 0.91. What is the ratio of the Imports(as % of merchandise exports) in Senegal in 2001 to that in 2002?
Offer a terse response. 1.03. What is the ratio of the Imports(as % of merchandise exports) of Small states in 2001 to that in 2003?
Your answer should be very brief. 1.01. What is the ratio of the Imports(as % of merchandise exports) in Cabo Verde in 2001 to that in 2003?
Keep it short and to the point. 1.1. What is the ratio of the Imports(as % of merchandise exports) of Lebanon in 2001 to that in 2003?
Provide a succinct answer. 0.95. What is the ratio of the Imports(as % of merchandise exports) in Senegal in 2001 to that in 2003?
Ensure brevity in your answer.  0.9. What is the ratio of the Imports(as % of merchandise exports) of Small states in 2001 to that in 2004?
Your answer should be very brief. 0.98. What is the ratio of the Imports(as % of merchandise exports) of Cabo Verde in 2001 to that in 2004?
Offer a terse response. 1.12. What is the ratio of the Imports(as % of merchandise exports) in Lebanon in 2001 to that in 2004?
Make the answer very short. 1.09. What is the ratio of the Imports(as % of merchandise exports) in Senegal in 2001 to that in 2004?
Ensure brevity in your answer.  0.95. What is the ratio of the Imports(as % of merchandise exports) of Small states in 2001 to that in 2005?
Ensure brevity in your answer.  1.06. What is the ratio of the Imports(as % of merchandise exports) in Cabo Verde in 2001 to that in 2005?
Give a very brief answer. 1.11. What is the ratio of the Imports(as % of merchandise exports) of Lebanon in 2001 to that in 2005?
Provide a short and direct response. 1.14. What is the ratio of the Imports(as % of merchandise exports) in Senegal in 2001 to that in 2005?
Make the answer very short. 0.95. What is the ratio of the Imports(as % of merchandise exports) in Small states in 2001 to that in 2006?
Your answer should be compact. 1.12. What is the ratio of the Imports(as % of merchandise exports) in Cabo Verde in 2001 to that in 2006?
Your answer should be compact. 1.16. What is the ratio of the Imports(as % of merchandise exports) in Lebanon in 2001 to that in 2006?
Offer a terse response. 1.15. What is the ratio of the Imports(as % of merchandise exports) in Senegal in 2001 to that in 2006?
Offer a terse response. 1.14. What is the ratio of the Imports(as % of merchandise exports) in Small states in 2001 to that in 2007?
Provide a short and direct response. 1.06. What is the ratio of the Imports(as % of merchandise exports) of Cabo Verde in 2001 to that in 2007?
Keep it short and to the point. 1.31. What is the ratio of the Imports(as % of merchandise exports) of Lebanon in 2001 to that in 2007?
Provide a succinct answer. 1.07. What is the ratio of the Imports(as % of merchandise exports) of Senegal in 2001 to that in 2007?
Provide a short and direct response. 1.07. What is the ratio of the Imports(as % of merchandise exports) of Small states in 2002 to that in 2003?
Provide a succinct answer. 1.03. What is the ratio of the Imports(as % of merchandise exports) in Cabo Verde in 2002 to that in 2003?
Make the answer very short. 0.97. What is the ratio of the Imports(as % of merchandise exports) in Lebanon in 2002 to that in 2003?
Offer a terse response. 1.04. What is the ratio of the Imports(as % of merchandise exports) in Senegal in 2002 to that in 2003?
Offer a terse response. 0.88. What is the ratio of the Imports(as % of merchandise exports) in Cabo Verde in 2002 to that in 2004?
Keep it short and to the point. 0.99. What is the ratio of the Imports(as % of merchandise exports) of Lebanon in 2002 to that in 2004?
Keep it short and to the point. 1.19. What is the ratio of the Imports(as % of merchandise exports) in Senegal in 2002 to that in 2004?
Give a very brief answer. 0.92. What is the ratio of the Imports(as % of merchandise exports) of Small states in 2002 to that in 2005?
Give a very brief answer. 1.08. What is the ratio of the Imports(as % of merchandise exports) in Cabo Verde in 2002 to that in 2005?
Ensure brevity in your answer.  0.98. What is the ratio of the Imports(as % of merchandise exports) in Lebanon in 2002 to that in 2005?
Provide a short and direct response. 1.25. What is the ratio of the Imports(as % of merchandise exports) in Senegal in 2002 to that in 2005?
Offer a terse response. 0.93. What is the ratio of the Imports(as % of merchandise exports) of Small states in 2002 to that in 2006?
Give a very brief answer. 1.14. What is the ratio of the Imports(as % of merchandise exports) in Cabo Verde in 2002 to that in 2006?
Offer a very short reply. 1.02. What is the ratio of the Imports(as % of merchandise exports) in Lebanon in 2002 to that in 2006?
Provide a short and direct response. 1.26. What is the ratio of the Imports(as % of merchandise exports) of Senegal in 2002 to that in 2006?
Make the answer very short. 1.12. What is the ratio of the Imports(as % of merchandise exports) of Small states in 2002 to that in 2007?
Offer a terse response. 1.08. What is the ratio of the Imports(as % of merchandise exports) of Cabo Verde in 2002 to that in 2007?
Offer a very short reply. 1.16. What is the ratio of the Imports(as % of merchandise exports) in Lebanon in 2002 to that in 2007?
Ensure brevity in your answer.  1.17. What is the ratio of the Imports(as % of merchandise exports) in Senegal in 2002 to that in 2007?
Your answer should be very brief. 1.04. What is the ratio of the Imports(as % of merchandise exports) in Small states in 2003 to that in 2004?
Offer a very short reply. 0.98. What is the ratio of the Imports(as % of merchandise exports) of Cabo Verde in 2003 to that in 2004?
Your answer should be compact. 1.02. What is the ratio of the Imports(as % of merchandise exports) in Lebanon in 2003 to that in 2004?
Offer a very short reply. 1.15. What is the ratio of the Imports(as % of merchandise exports) of Senegal in 2003 to that in 2004?
Offer a very short reply. 1.05. What is the ratio of the Imports(as % of merchandise exports) of Small states in 2003 to that in 2005?
Your answer should be very brief. 1.05. What is the ratio of the Imports(as % of merchandise exports) in Cabo Verde in 2003 to that in 2005?
Offer a terse response. 1.01. What is the ratio of the Imports(as % of merchandise exports) of Lebanon in 2003 to that in 2005?
Your response must be concise. 1.2. What is the ratio of the Imports(as % of merchandise exports) in Senegal in 2003 to that in 2005?
Offer a terse response. 1.05. What is the ratio of the Imports(as % of merchandise exports) of Small states in 2003 to that in 2006?
Provide a succinct answer. 1.11. What is the ratio of the Imports(as % of merchandise exports) in Cabo Verde in 2003 to that in 2006?
Provide a succinct answer. 1.05. What is the ratio of the Imports(as % of merchandise exports) of Lebanon in 2003 to that in 2006?
Make the answer very short. 1.21. What is the ratio of the Imports(as % of merchandise exports) of Senegal in 2003 to that in 2006?
Your response must be concise. 1.27. What is the ratio of the Imports(as % of merchandise exports) of Small states in 2003 to that in 2007?
Give a very brief answer. 1.06. What is the ratio of the Imports(as % of merchandise exports) of Cabo Verde in 2003 to that in 2007?
Your answer should be compact. 1.2. What is the ratio of the Imports(as % of merchandise exports) of Lebanon in 2003 to that in 2007?
Keep it short and to the point. 1.12. What is the ratio of the Imports(as % of merchandise exports) of Senegal in 2003 to that in 2007?
Offer a terse response. 1.18. What is the ratio of the Imports(as % of merchandise exports) of Small states in 2004 to that in 2005?
Keep it short and to the point. 1.07. What is the ratio of the Imports(as % of merchandise exports) of Cabo Verde in 2004 to that in 2005?
Keep it short and to the point. 0.99. What is the ratio of the Imports(as % of merchandise exports) in Lebanon in 2004 to that in 2005?
Offer a terse response. 1.04. What is the ratio of the Imports(as % of merchandise exports) in Senegal in 2004 to that in 2005?
Keep it short and to the point. 1. What is the ratio of the Imports(as % of merchandise exports) in Small states in 2004 to that in 2006?
Your answer should be compact. 1.13. What is the ratio of the Imports(as % of merchandise exports) of Cabo Verde in 2004 to that in 2006?
Give a very brief answer. 1.04. What is the ratio of the Imports(as % of merchandise exports) in Lebanon in 2004 to that in 2006?
Your response must be concise. 1.05. What is the ratio of the Imports(as % of merchandise exports) of Senegal in 2004 to that in 2006?
Provide a short and direct response. 1.21. What is the ratio of the Imports(as % of merchandise exports) in Small states in 2004 to that in 2007?
Your answer should be very brief. 1.08. What is the ratio of the Imports(as % of merchandise exports) in Cabo Verde in 2004 to that in 2007?
Offer a very short reply. 1.18. What is the ratio of the Imports(as % of merchandise exports) in Lebanon in 2004 to that in 2007?
Your response must be concise. 0.98. What is the ratio of the Imports(as % of merchandise exports) in Senegal in 2004 to that in 2007?
Ensure brevity in your answer.  1.13. What is the ratio of the Imports(as % of merchandise exports) of Small states in 2005 to that in 2006?
Make the answer very short. 1.06. What is the ratio of the Imports(as % of merchandise exports) in Cabo Verde in 2005 to that in 2006?
Your answer should be very brief. 1.05. What is the ratio of the Imports(as % of merchandise exports) in Lebanon in 2005 to that in 2006?
Ensure brevity in your answer.  1.01. What is the ratio of the Imports(as % of merchandise exports) in Senegal in 2005 to that in 2006?
Make the answer very short. 1.2. What is the ratio of the Imports(as % of merchandise exports) in Small states in 2005 to that in 2007?
Keep it short and to the point. 1.01. What is the ratio of the Imports(as % of merchandise exports) in Cabo Verde in 2005 to that in 2007?
Provide a short and direct response. 1.19. What is the ratio of the Imports(as % of merchandise exports) in Lebanon in 2005 to that in 2007?
Ensure brevity in your answer.  0.94. What is the ratio of the Imports(as % of merchandise exports) of Senegal in 2005 to that in 2007?
Provide a short and direct response. 1.12. What is the ratio of the Imports(as % of merchandise exports) in Small states in 2006 to that in 2007?
Your answer should be compact. 0.95. What is the ratio of the Imports(as % of merchandise exports) in Cabo Verde in 2006 to that in 2007?
Ensure brevity in your answer.  1.14. What is the ratio of the Imports(as % of merchandise exports) in Lebanon in 2006 to that in 2007?
Your response must be concise. 0.93. What is the ratio of the Imports(as % of merchandise exports) of Senegal in 2006 to that in 2007?
Give a very brief answer. 0.93. What is the difference between the highest and the second highest Imports(as % of merchandise exports) of Small states?
Your answer should be compact. 0.05. What is the difference between the highest and the second highest Imports(as % of merchandise exports) of Cabo Verde?
Give a very brief answer. 2.74. What is the difference between the highest and the second highest Imports(as % of merchandise exports) in Lebanon?
Offer a very short reply. 0.32. What is the difference between the highest and the second highest Imports(as % of merchandise exports) of Senegal?
Make the answer very short. 1.34. What is the difference between the highest and the lowest Imports(as % of merchandise exports) in Small states?
Provide a short and direct response. 2.01. What is the difference between the highest and the lowest Imports(as % of merchandise exports) of Cabo Verde?
Your response must be concise. 8.05. What is the difference between the highest and the lowest Imports(as % of merchandise exports) in Lebanon?
Offer a very short reply. 3.97. What is the difference between the highest and the lowest Imports(as % of merchandise exports) in Senegal?
Your answer should be compact. 6.3. 